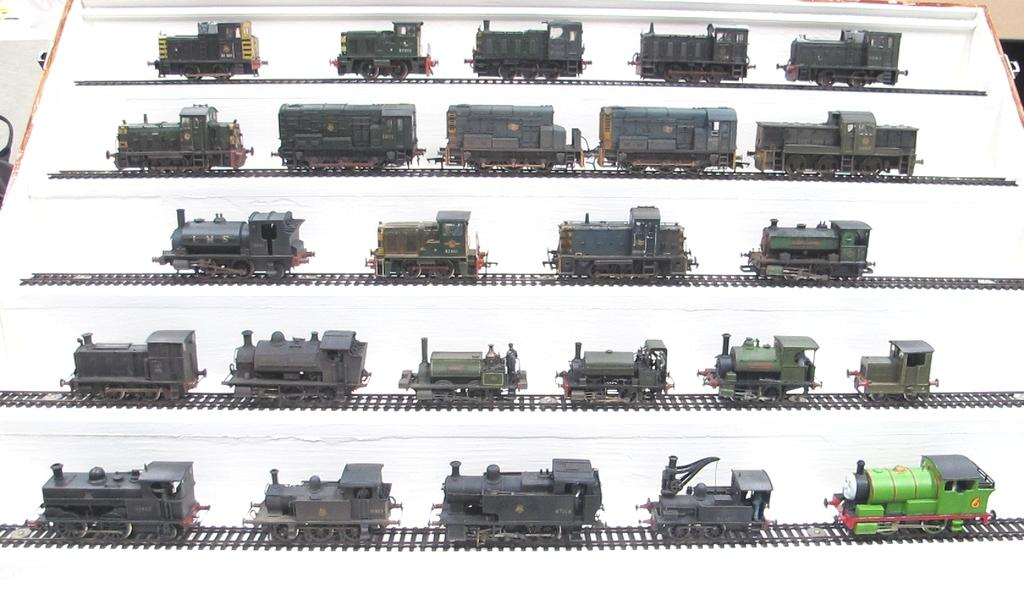What type of toy set is in the picture? The toy set in the picture includes train engines and train tracks. What are the main components of the toy set? The main components of the toy set are train engines and train tracks. Can you see a kite flying in the garden in the picture? There is no garden or kite present in the picture; it features a toy set with train engines and train tracks. 